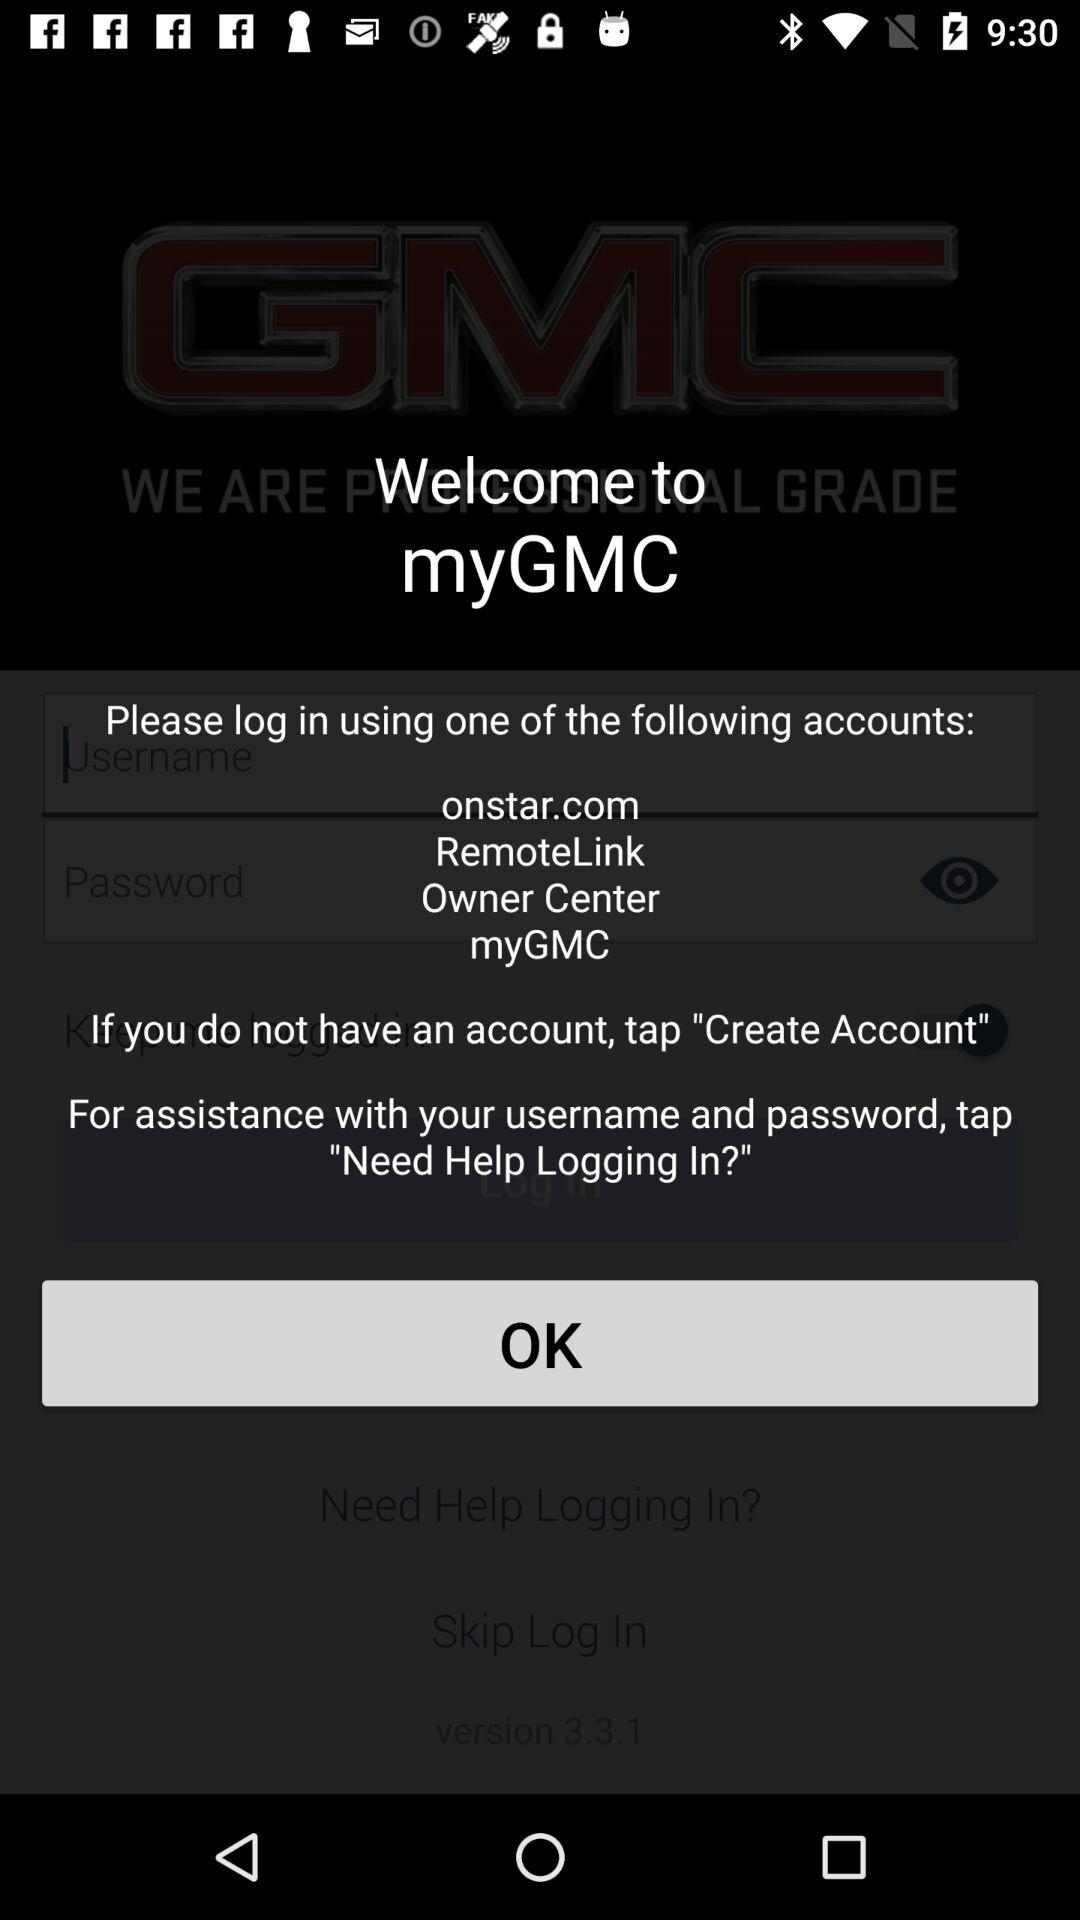Which accounts can I use to log in? You can use "onstar.com", "RemoteLink", "Owner Center" and "myGMC" accounts to log in. 